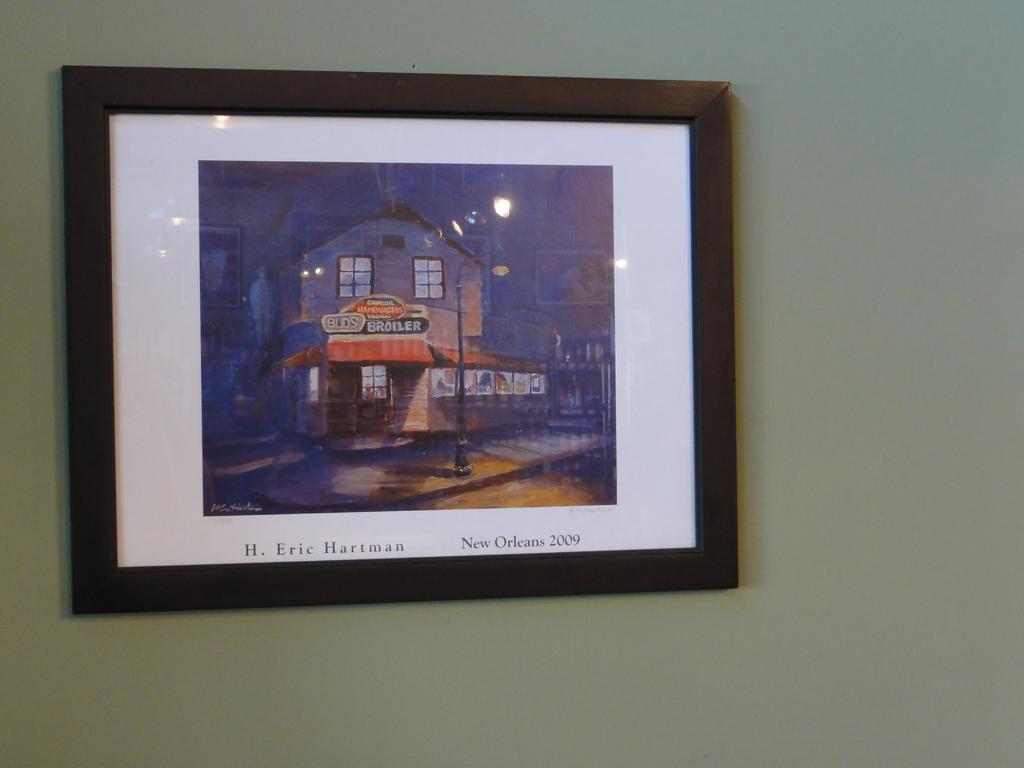<image>
Render a clear and concise summary of the photo. A picture from New Orleans by H. Eric Hartman. 